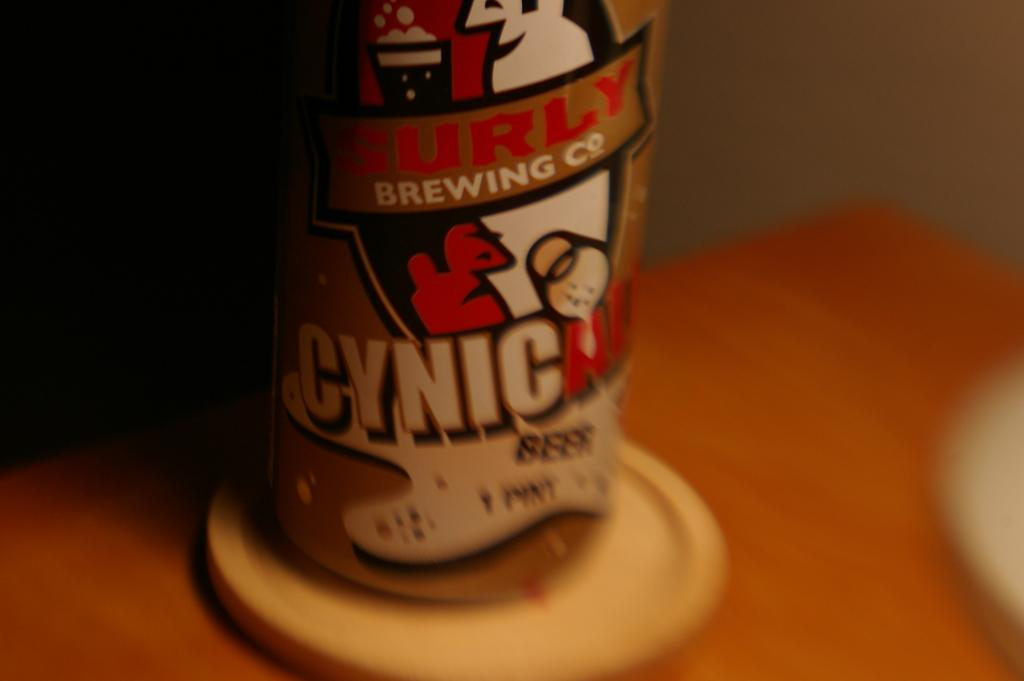<image>
Give a short and clear explanation of the subsequent image. a can that says cynic on the front of it 